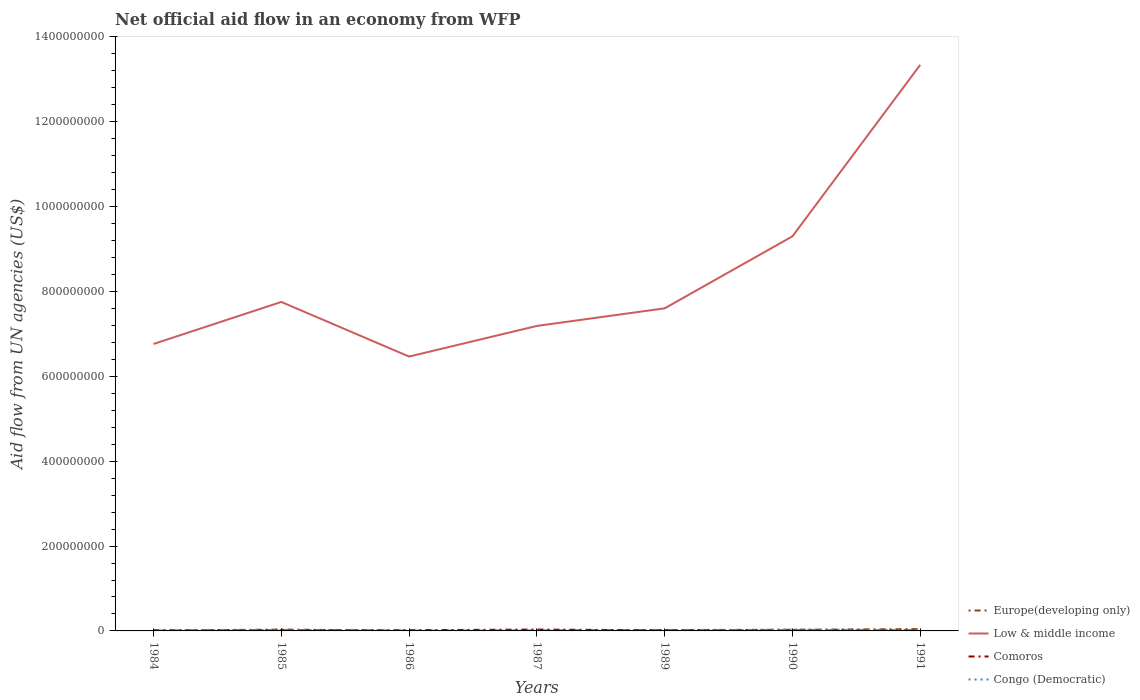Is the number of lines equal to the number of legend labels?
Your answer should be very brief. Yes. Across all years, what is the maximum net official aid flow in Europe(developing only)?
Ensure brevity in your answer.  4.70e+05. What is the total net official aid flow in Europe(developing only) in the graph?
Your answer should be compact. 2.37e+06. What is the difference between the highest and the second highest net official aid flow in Congo (Democratic)?
Keep it short and to the point. 3.17e+06. What is the difference between the highest and the lowest net official aid flow in Comoros?
Your response must be concise. 2. Does the graph contain grids?
Provide a short and direct response. No. How many legend labels are there?
Offer a very short reply. 4. How are the legend labels stacked?
Your answer should be compact. Vertical. What is the title of the graph?
Keep it short and to the point. Net official aid flow in an economy from WFP. What is the label or title of the Y-axis?
Your answer should be very brief. Aid flow from UN agencies (US$). What is the Aid flow from UN agencies (US$) of Europe(developing only) in 1984?
Provide a succinct answer. 5.50e+05. What is the Aid flow from UN agencies (US$) of Low & middle income in 1984?
Give a very brief answer. 6.76e+08. What is the Aid flow from UN agencies (US$) in Comoros in 1984?
Offer a terse response. 1.48e+06. What is the Aid flow from UN agencies (US$) in Europe(developing only) in 1985?
Your answer should be very brief. 3.30e+06. What is the Aid flow from UN agencies (US$) of Low & middle income in 1985?
Offer a very short reply. 7.75e+08. What is the Aid flow from UN agencies (US$) in Comoros in 1985?
Make the answer very short. 1.28e+06. What is the Aid flow from UN agencies (US$) of Congo (Democratic) in 1985?
Provide a short and direct response. 2.42e+06. What is the Aid flow from UN agencies (US$) of Europe(developing only) in 1986?
Give a very brief answer. 4.70e+05. What is the Aid flow from UN agencies (US$) in Low & middle income in 1986?
Your answer should be very brief. 6.47e+08. What is the Aid flow from UN agencies (US$) of Comoros in 1986?
Make the answer very short. 1.69e+06. What is the Aid flow from UN agencies (US$) in Congo (Democratic) in 1986?
Your answer should be compact. 1.80e+05. What is the Aid flow from UN agencies (US$) of Europe(developing only) in 1987?
Offer a terse response. 9.30e+05. What is the Aid flow from UN agencies (US$) of Low & middle income in 1987?
Your answer should be very brief. 7.19e+08. What is the Aid flow from UN agencies (US$) of Comoros in 1987?
Your answer should be compact. 3.21e+06. What is the Aid flow from UN agencies (US$) in Congo (Democratic) in 1987?
Provide a short and direct response. 7.20e+05. What is the Aid flow from UN agencies (US$) in Europe(developing only) in 1989?
Offer a very short reply. 2.12e+06. What is the Aid flow from UN agencies (US$) in Low & middle income in 1989?
Offer a terse response. 7.60e+08. What is the Aid flow from UN agencies (US$) of Comoros in 1989?
Make the answer very short. 1.46e+06. What is the Aid flow from UN agencies (US$) in Congo (Democratic) in 1989?
Ensure brevity in your answer.  4.40e+05. What is the Aid flow from UN agencies (US$) of Europe(developing only) in 1990?
Your response must be concise. 2.73e+06. What is the Aid flow from UN agencies (US$) of Low & middle income in 1990?
Offer a very short reply. 9.30e+08. What is the Aid flow from UN agencies (US$) of Comoros in 1990?
Your answer should be compact. 1.21e+06. What is the Aid flow from UN agencies (US$) in Congo (Democratic) in 1990?
Provide a short and direct response. 3.23e+06. What is the Aid flow from UN agencies (US$) of Europe(developing only) in 1991?
Your response must be concise. 4.31e+06. What is the Aid flow from UN agencies (US$) in Low & middle income in 1991?
Offer a terse response. 1.33e+09. What is the Aid flow from UN agencies (US$) of Comoros in 1991?
Your answer should be very brief. 9.40e+05. What is the Aid flow from UN agencies (US$) in Congo (Democratic) in 1991?
Your answer should be very brief. 2.19e+06. Across all years, what is the maximum Aid flow from UN agencies (US$) in Europe(developing only)?
Your response must be concise. 4.31e+06. Across all years, what is the maximum Aid flow from UN agencies (US$) in Low & middle income?
Make the answer very short. 1.33e+09. Across all years, what is the maximum Aid flow from UN agencies (US$) of Comoros?
Your answer should be compact. 3.21e+06. Across all years, what is the maximum Aid flow from UN agencies (US$) in Congo (Democratic)?
Offer a terse response. 3.23e+06. Across all years, what is the minimum Aid flow from UN agencies (US$) in Low & middle income?
Provide a short and direct response. 6.47e+08. Across all years, what is the minimum Aid flow from UN agencies (US$) in Comoros?
Give a very brief answer. 9.40e+05. Across all years, what is the minimum Aid flow from UN agencies (US$) of Congo (Democratic)?
Provide a short and direct response. 6.00e+04. What is the total Aid flow from UN agencies (US$) in Europe(developing only) in the graph?
Give a very brief answer. 1.44e+07. What is the total Aid flow from UN agencies (US$) in Low & middle income in the graph?
Give a very brief answer. 5.84e+09. What is the total Aid flow from UN agencies (US$) of Comoros in the graph?
Your answer should be compact. 1.13e+07. What is the total Aid flow from UN agencies (US$) in Congo (Democratic) in the graph?
Your response must be concise. 9.24e+06. What is the difference between the Aid flow from UN agencies (US$) in Europe(developing only) in 1984 and that in 1985?
Keep it short and to the point. -2.75e+06. What is the difference between the Aid flow from UN agencies (US$) of Low & middle income in 1984 and that in 1985?
Make the answer very short. -9.91e+07. What is the difference between the Aid flow from UN agencies (US$) of Congo (Democratic) in 1984 and that in 1985?
Your answer should be very brief. -2.36e+06. What is the difference between the Aid flow from UN agencies (US$) in Low & middle income in 1984 and that in 1986?
Provide a short and direct response. 2.97e+07. What is the difference between the Aid flow from UN agencies (US$) in Comoros in 1984 and that in 1986?
Provide a short and direct response. -2.10e+05. What is the difference between the Aid flow from UN agencies (US$) of Congo (Democratic) in 1984 and that in 1986?
Make the answer very short. -1.20e+05. What is the difference between the Aid flow from UN agencies (US$) in Europe(developing only) in 1984 and that in 1987?
Provide a succinct answer. -3.80e+05. What is the difference between the Aid flow from UN agencies (US$) in Low & middle income in 1984 and that in 1987?
Provide a short and direct response. -4.26e+07. What is the difference between the Aid flow from UN agencies (US$) of Comoros in 1984 and that in 1987?
Provide a short and direct response. -1.73e+06. What is the difference between the Aid flow from UN agencies (US$) in Congo (Democratic) in 1984 and that in 1987?
Provide a succinct answer. -6.60e+05. What is the difference between the Aid flow from UN agencies (US$) of Europe(developing only) in 1984 and that in 1989?
Ensure brevity in your answer.  -1.57e+06. What is the difference between the Aid flow from UN agencies (US$) of Low & middle income in 1984 and that in 1989?
Your answer should be compact. -8.40e+07. What is the difference between the Aid flow from UN agencies (US$) in Congo (Democratic) in 1984 and that in 1989?
Your answer should be compact. -3.80e+05. What is the difference between the Aid flow from UN agencies (US$) of Europe(developing only) in 1984 and that in 1990?
Your answer should be very brief. -2.18e+06. What is the difference between the Aid flow from UN agencies (US$) in Low & middle income in 1984 and that in 1990?
Your answer should be very brief. -2.54e+08. What is the difference between the Aid flow from UN agencies (US$) of Comoros in 1984 and that in 1990?
Provide a short and direct response. 2.70e+05. What is the difference between the Aid flow from UN agencies (US$) of Congo (Democratic) in 1984 and that in 1990?
Provide a succinct answer. -3.17e+06. What is the difference between the Aid flow from UN agencies (US$) of Europe(developing only) in 1984 and that in 1991?
Your answer should be compact. -3.76e+06. What is the difference between the Aid flow from UN agencies (US$) of Low & middle income in 1984 and that in 1991?
Offer a terse response. -6.58e+08. What is the difference between the Aid flow from UN agencies (US$) of Comoros in 1984 and that in 1991?
Provide a short and direct response. 5.40e+05. What is the difference between the Aid flow from UN agencies (US$) in Congo (Democratic) in 1984 and that in 1991?
Make the answer very short. -2.13e+06. What is the difference between the Aid flow from UN agencies (US$) in Europe(developing only) in 1985 and that in 1986?
Offer a terse response. 2.83e+06. What is the difference between the Aid flow from UN agencies (US$) in Low & middle income in 1985 and that in 1986?
Offer a very short reply. 1.29e+08. What is the difference between the Aid flow from UN agencies (US$) of Comoros in 1985 and that in 1986?
Provide a succinct answer. -4.10e+05. What is the difference between the Aid flow from UN agencies (US$) of Congo (Democratic) in 1985 and that in 1986?
Offer a very short reply. 2.24e+06. What is the difference between the Aid flow from UN agencies (US$) of Europe(developing only) in 1985 and that in 1987?
Your response must be concise. 2.37e+06. What is the difference between the Aid flow from UN agencies (US$) in Low & middle income in 1985 and that in 1987?
Provide a succinct answer. 5.65e+07. What is the difference between the Aid flow from UN agencies (US$) in Comoros in 1985 and that in 1987?
Provide a short and direct response. -1.93e+06. What is the difference between the Aid flow from UN agencies (US$) of Congo (Democratic) in 1985 and that in 1987?
Your response must be concise. 1.70e+06. What is the difference between the Aid flow from UN agencies (US$) of Europe(developing only) in 1985 and that in 1989?
Your answer should be compact. 1.18e+06. What is the difference between the Aid flow from UN agencies (US$) of Low & middle income in 1985 and that in 1989?
Provide a short and direct response. 1.51e+07. What is the difference between the Aid flow from UN agencies (US$) in Congo (Democratic) in 1985 and that in 1989?
Your response must be concise. 1.98e+06. What is the difference between the Aid flow from UN agencies (US$) in Europe(developing only) in 1985 and that in 1990?
Offer a terse response. 5.70e+05. What is the difference between the Aid flow from UN agencies (US$) of Low & middle income in 1985 and that in 1990?
Your answer should be very brief. -1.55e+08. What is the difference between the Aid flow from UN agencies (US$) in Congo (Democratic) in 1985 and that in 1990?
Make the answer very short. -8.10e+05. What is the difference between the Aid flow from UN agencies (US$) in Europe(developing only) in 1985 and that in 1991?
Keep it short and to the point. -1.01e+06. What is the difference between the Aid flow from UN agencies (US$) of Low & middle income in 1985 and that in 1991?
Offer a very short reply. -5.59e+08. What is the difference between the Aid flow from UN agencies (US$) in Congo (Democratic) in 1985 and that in 1991?
Provide a short and direct response. 2.30e+05. What is the difference between the Aid flow from UN agencies (US$) of Europe(developing only) in 1986 and that in 1987?
Provide a succinct answer. -4.60e+05. What is the difference between the Aid flow from UN agencies (US$) of Low & middle income in 1986 and that in 1987?
Give a very brief answer. -7.22e+07. What is the difference between the Aid flow from UN agencies (US$) of Comoros in 1986 and that in 1987?
Keep it short and to the point. -1.52e+06. What is the difference between the Aid flow from UN agencies (US$) in Congo (Democratic) in 1986 and that in 1987?
Keep it short and to the point. -5.40e+05. What is the difference between the Aid flow from UN agencies (US$) of Europe(developing only) in 1986 and that in 1989?
Your response must be concise. -1.65e+06. What is the difference between the Aid flow from UN agencies (US$) in Low & middle income in 1986 and that in 1989?
Provide a short and direct response. -1.14e+08. What is the difference between the Aid flow from UN agencies (US$) in Comoros in 1986 and that in 1989?
Your answer should be compact. 2.30e+05. What is the difference between the Aid flow from UN agencies (US$) in Europe(developing only) in 1986 and that in 1990?
Keep it short and to the point. -2.26e+06. What is the difference between the Aid flow from UN agencies (US$) in Low & middle income in 1986 and that in 1990?
Offer a very short reply. -2.83e+08. What is the difference between the Aid flow from UN agencies (US$) in Comoros in 1986 and that in 1990?
Make the answer very short. 4.80e+05. What is the difference between the Aid flow from UN agencies (US$) of Congo (Democratic) in 1986 and that in 1990?
Your answer should be compact. -3.05e+06. What is the difference between the Aid flow from UN agencies (US$) of Europe(developing only) in 1986 and that in 1991?
Your response must be concise. -3.84e+06. What is the difference between the Aid flow from UN agencies (US$) in Low & middle income in 1986 and that in 1991?
Offer a very short reply. -6.88e+08. What is the difference between the Aid flow from UN agencies (US$) of Comoros in 1986 and that in 1991?
Your response must be concise. 7.50e+05. What is the difference between the Aid flow from UN agencies (US$) of Congo (Democratic) in 1986 and that in 1991?
Ensure brevity in your answer.  -2.01e+06. What is the difference between the Aid flow from UN agencies (US$) of Europe(developing only) in 1987 and that in 1989?
Offer a very short reply. -1.19e+06. What is the difference between the Aid flow from UN agencies (US$) in Low & middle income in 1987 and that in 1989?
Your response must be concise. -4.15e+07. What is the difference between the Aid flow from UN agencies (US$) of Comoros in 1987 and that in 1989?
Keep it short and to the point. 1.75e+06. What is the difference between the Aid flow from UN agencies (US$) of Europe(developing only) in 1987 and that in 1990?
Ensure brevity in your answer.  -1.80e+06. What is the difference between the Aid flow from UN agencies (US$) of Low & middle income in 1987 and that in 1990?
Offer a terse response. -2.11e+08. What is the difference between the Aid flow from UN agencies (US$) of Congo (Democratic) in 1987 and that in 1990?
Make the answer very short. -2.51e+06. What is the difference between the Aid flow from UN agencies (US$) in Europe(developing only) in 1987 and that in 1991?
Your answer should be very brief. -3.38e+06. What is the difference between the Aid flow from UN agencies (US$) of Low & middle income in 1987 and that in 1991?
Offer a very short reply. -6.15e+08. What is the difference between the Aid flow from UN agencies (US$) of Comoros in 1987 and that in 1991?
Make the answer very short. 2.27e+06. What is the difference between the Aid flow from UN agencies (US$) in Congo (Democratic) in 1987 and that in 1991?
Your response must be concise. -1.47e+06. What is the difference between the Aid flow from UN agencies (US$) of Europe(developing only) in 1989 and that in 1990?
Offer a very short reply. -6.10e+05. What is the difference between the Aid flow from UN agencies (US$) of Low & middle income in 1989 and that in 1990?
Offer a very short reply. -1.70e+08. What is the difference between the Aid flow from UN agencies (US$) of Comoros in 1989 and that in 1990?
Keep it short and to the point. 2.50e+05. What is the difference between the Aid flow from UN agencies (US$) of Congo (Democratic) in 1989 and that in 1990?
Keep it short and to the point. -2.79e+06. What is the difference between the Aid flow from UN agencies (US$) in Europe(developing only) in 1989 and that in 1991?
Provide a succinct answer. -2.19e+06. What is the difference between the Aid flow from UN agencies (US$) in Low & middle income in 1989 and that in 1991?
Provide a short and direct response. -5.74e+08. What is the difference between the Aid flow from UN agencies (US$) in Comoros in 1989 and that in 1991?
Give a very brief answer. 5.20e+05. What is the difference between the Aid flow from UN agencies (US$) in Congo (Democratic) in 1989 and that in 1991?
Offer a very short reply. -1.75e+06. What is the difference between the Aid flow from UN agencies (US$) in Europe(developing only) in 1990 and that in 1991?
Provide a succinct answer. -1.58e+06. What is the difference between the Aid flow from UN agencies (US$) of Low & middle income in 1990 and that in 1991?
Keep it short and to the point. -4.04e+08. What is the difference between the Aid flow from UN agencies (US$) of Comoros in 1990 and that in 1991?
Ensure brevity in your answer.  2.70e+05. What is the difference between the Aid flow from UN agencies (US$) in Congo (Democratic) in 1990 and that in 1991?
Make the answer very short. 1.04e+06. What is the difference between the Aid flow from UN agencies (US$) in Europe(developing only) in 1984 and the Aid flow from UN agencies (US$) in Low & middle income in 1985?
Your answer should be very brief. -7.75e+08. What is the difference between the Aid flow from UN agencies (US$) of Europe(developing only) in 1984 and the Aid flow from UN agencies (US$) of Comoros in 1985?
Your answer should be very brief. -7.30e+05. What is the difference between the Aid flow from UN agencies (US$) in Europe(developing only) in 1984 and the Aid flow from UN agencies (US$) in Congo (Democratic) in 1985?
Give a very brief answer. -1.87e+06. What is the difference between the Aid flow from UN agencies (US$) of Low & middle income in 1984 and the Aid flow from UN agencies (US$) of Comoros in 1985?
Offer a very short reply. 6.75e+08. What is the difference between the Aid flow from UN agencies (US$) of Low & middle income in 1984 and the Aid flow from UN agencies (US$) of Congo (Democratic) in 1985?
Keep it short and to the point. 6.74e+08. What is the difference between the Aid flow from UN agencies (US$) in Comoros in 1984 and the Aid flow from UN agencies (US$) in Congo (Democratic) in 1985?
Give a very brief answer. -9.40e+05. What is the difference between the Aid flow from UN agencies (US$) in Europe(developing only) in 1984 and the Aid flow from UN agencies (US$) in Low & middle income in 1986?
Offer a very short reply. -6.46e+08. What is the difference between the Aid flow from UN agencies (US$) of Europe(developing only) in 1984 and the Aid flow from UN agencies (US$) of Comoros in 1986?
Give a very brief answer. -1.14e+06. What is the difference between the Aid flow from UN agencies (US$) in Europe(developing only) in 1984 and the Aid flow from UN agencies (US$) in Congo (Democratic) in 1986?
Offer a very short reply. 3.70e+05. What is the difference between the Aid flow from UN agencies (US$) of Low & middle income in 1984 and the Aid flow from UN agencies (US$) of Comoros in 1986?
Offer a terse response. 6.75e+08. What is the difference between the Aid flow from UN agencies (US$) in Low & middle income in 1984 and the Aid flow from UN agencies (US$) in Congo (Democratic) in 1986?
Offer a terse response. 6.76e+08. What is the difference between the Aid flow from UN agencies (US$) in Comoros in 1984 and the Aid flow from UN agencies (US$) in Congo (Democratic) in 1986?
Provide a succinct answer. 1.30e+06. What is the difference between the Aid flow from UN agencies (US$) in Europe(developing only) in 1984 and the Aid flow from UN agencies (US$) in Low & middle income in 1987?
Ensure brevity in your answer.  -7.18e+08. What is the difference between the Aid flow from UN agencies (US$) of Europe(developing only) in 1984 and the Aid flow from UN agencies (US$) of Comoros in 1987?
Provide a short and direct response. -2.66e+06. What is the difference between the Aid flow from UN agencies (US$) in Low & middle income in 1984 and the Aid flow from UN agencies (US$) in Comoros in 1987?
Offer a very short reply. 6.73e+08. What is the difference between the Aid flow from UN agencies (US$) in Low & middle income in 1984 and the Aid flow from UN agencies (US$) in Congo (Democratic) in 1987?
Your answer should be very brief. 6.76e+08. What is the difference between the Aid flow from UN agencies (US$) in Comoros in 1984 and the Aid flow from UN agencies (US$) in Congo (Democratic) in 1987?
Offer a terse response. 7.60e+05. What is the difference between the Aid flow from UN agencies (US$) of Europe(developing only) in 1984 and the Aid flow from UN agencies (US$) of Low & middle income in 1989?
Make the answer very short. -7.60e+08. What is the difference between the Aid flow from UN agencies (US$) in Europe(developing only) in 1984 and the Aid flow from UN agencies (US$) in Comoros in 1989?
Make the answer very short. -9.10e+05. What is the difference between the Aid flow from UN agencies (US$) in Low & middle income in 1984 and the Aid flow from UN agencies (US$) in Comoros in 1989?
Your answer should be compact. 6.75e+08. What is the difference between the Aid flow from UN agencies (US$) of Low & middle income in 1984 and the Aid flow from UN agencies (US$) of Congo (Democratic) in 1989?
Keep it short and to the point. 6.76e+08. What is the difference between the Aid flow from UN agencies (US$) in Comoros in 1984 and the Aid flow from UN agencies (US$) in Congo (Democratic) in 1989?
Your answer should be very brief. 1.04e+06. What is the difference between the Aid flow from UN agencies (US$) in Europe(developing only) in 1984 and the Aid flow from UN agencies (US$) in Low & middle income in 1990?
Ensure brevity in your answer.  -9.29e+08. What is the difference between the Aid flow from UN agencies (US$) of Europe(developing only) in 1984 and the Aid flow from UN agencies (US$) of Comoros in 1990?
Provide a short and direct response. -6.60e+05. What is the difference between the Aid flow from UN agencies (US$) in Europe(developing only) in 1984 and the Aid flow from UN agencies (US$) in Congo (Democratic) in 1990?
Ensure brevity in your answer.  -2.68e+06. What is the difference between the Aid flow from UN agencies (US$) of Low & middle income in 1984 and the Aid flow from UN agencies (US$) of Comoros in 1990?
Provide a succinct answer. 6.75e+08. What is the difference between the Aid flow from UN agencies (US$) of Low & middle income in 1984 and the Aid flow from UN agencies (US$) of Congo (Democratic) in 1990?
Your answer should be very brief. 6.73e+08. What is the difference between the Aid flow from UN agencies (US$) of Comoros in 1984 and the Aid flow from UN agencies (US$) of Congo (Democratic) in 1990?
Your answer should be very brief. -1.75e+06. What is the difference between the Aid flow from UN agencies (US$) of Europe(developing only) in 1984 and the Aid flow from UN agencies (US$) of Low & middle income in 1991?
Your answer should be very brief. -1.33e+09. What is the difference between the Aid flow from UN agencies (US$) of Europe(developing only) in 1984 and the Aid flow from UN agencies (US$) of Comoros in 1991?
Make the answer very short. -3.90e+05. What is the difference between the Aid flow from UN agencies (US$) of Europe(developing only) in 1984 and the Aid flow from UN agencies (US$) of Congo (Democratic) in 1991?
Your answer should be compact. -1.64e+06. What is the difference between the Aid flow from UN agencies (US$) in Low & middle income in 1984 and the Aid flow from UN agencies (US$) in Comoros in 1991?
Provide a short and direct response. 6.75e+08. What is the difference between the Aid flow from UN agencies (US$) of Low & middle income in 1984 and the Aid flow from UN agencies (US$) of Congo (Democratic) in 1991?
Make the answer very short. 6.74e+08. What is the difference between the Aid flow from UN agencies (US$) of Comoros in 1984 and the Aid flow from UN agencies (US$) of Congo (Democratic) in 1991?
Make the answer very short. -7.10e+05. What is the difference between the Aid flow from UN agencies (US$) of Europe(developing only) in 1985 and the Aid flow from UN agencies (US$) of Low & middle income in 1986?
Give a very brief answer. -6.43e+08. What is the difference between the Aid flow from UN agencies (US$) of Europe(developing only) in 1985 and the Aid flow from UN agencies (US$) of Comoros in 1986?
Offer a very short reply. 1.61e+06. What is the difference between the Aid flow from UN agencies (US$) of Europe(developing only) in 1985 and the Aid flow from UN agencies (US$) of Congo (Democratic) in 1986?
Your answer should be compact. 3.12e+06. What is the difference between the Aid flow from UN agencies (US$) of Low & middle income in 1985 and the Aid flow from UN agencies (US$) of Comoros in 1986?
Your answer should be compact. 7.74e+08. What is the difference between the Aid flow from UN agencies (US$) of Low & middle income in 1985 and the Aid flow from UN agencies (US$) of Congo (Democratic) in 1986?
Give a very brief answer. 7.75e+08. What is the difference between the Aid flow from UN agencies (US$) in Comoros in 1985 and the Aid flow from UN agencies (US$) in Congo (Democratic) in 1986?
Your answer should be very brief. 1.10e+06. What is the difference between the Aid flow from UN agencies (US$) of Europe(developing only) in 1985 and the Aid flow from UN agencies (US$) of Low & middle income in 1987?
Keep it short and to the point. -7.16e+08. What is the difference between the Aid flow from UN agencies (US$) in Europe(developing only) in 1985 and the Aid flow from UN agencies (US$) in Comoros in 1987?
Your answer should be very brief. 9.00e+04. What is the difference between the Aid flow from UN agencies (US$) of Europe(developing only) in 1985 and the Aid flow from UN agencies (US$) of Congo (Democratic) in 1987?
Offer a very short reply. 2.58e+06. What is the difference between the Aid flow from UN agencies (US$) of Low & middle income in 1985 and the Aid flow from UN agencies (US$) of Comoros in 1987?
Provide a short and direct response. 7.72e+08. What is the difference between the Aid flow from UN agencies (US$) of Low & middle income in 1985 and the Aid flow from UN agencies (US$) of Congo (Democratic) in 1987?
Provide a succinct answer. 7.75e+08. What is the difference between the Aid flow from UN agencies (US$) in Comoros in 1985 and the Aid flow from UN agencies (US$) in Congo (Democratic) in 1987?
Keep it short and to the point. 5.60e+05. What is the difference between the Aid flow from UN agencies (US$) in Europe(developing only) in 1985 and the Aid flow from UN agencies (US$) in Low & middle income in 1989?
Keep it short and to the point. -7.57e+08. What is the difference between the Aid flow from UN agencies (US$) of Europe(developing only) in 1985 and the Aid flow from UN agencies (US$) of Comoros in 1989?
Provide a succinct answer. 1.84e+06. What is the difference between the Aid flow from UN agencies (US$) in Europe(developing only) in 1985 and the Aid flow from UN agencies (US$) in Congo (Democratic) in 1989?
Offer a very short reply. 2.86e+06. What is the difference between the Aid flow from UN agencies (US$) of Low & middle income in 1985 and the Aid flow from UN agencies (US$) of Comoros in 1989?
Your answer should be compact. 7.74e+08. What is the difference between the Aid flow from UN agencies (US$) in Low & middle income in 1985 and the Aid flow from UN agencies (US$) in Congo (Democratic) in 1989?
Provide a short and direct response. 7.75e+08. What is the difference between the Aid flow from UN agencies (US$) in Comoros in 1985 and the Aid flow from UN agencies (US$) in Congo (Democratic) in 1989?
Keep it short and to the point. 8.40e+05. What is the difference between the Aid flow from UN agencies (US$) in Europe(developing only) in 1985 and the Aid flow from UN agencies (US$) in Low & middle income in 1990?
Offer a terse response. -9.27e+08. What is the difference between the Aid flow from UN agencies (US$) of Europe(developing only) in 1985 and the Aid flow from UN agencies (US$) of Comoros in 1990?
Your answer should be compact. 2.09e+06. What is the difference between the Aid flow from UN agencies (US$) in Europe(developing only) in 1985 and the Aid flow from UN agencies (US$) in Congo (Democratic) in 1990?
Your answer should be very brief. 7.00e+04. What is the difference between the Aid flow from UN agencies (US$) in Low & middle income in 1985 and the Aid flow from UN agencies (US$) in Comoros in 1990?
Give a very brief answer. 7.74e+08. What is the difference between the Aid flow from UN agencies (US$) in Low & middle income in 1985 and the Aid flow from UN agencies (US$) in Congo (Democratic) in 1990?
Ensure brevity in your answer.  7.72e+08. What is the difference between the Aid flow from UN agencies (US$) of Comoros in 1985 and the Aid flow from UN agencies (US$) of Congo (Democratic) in 1990?
Your answer should be very brief. -1.95e+06. What is the difference between the Aid flow from UN agencies (US$) of Europe(developing only) in 1985 and the Aid flow from UN agencies (US$) of Low & middle income in 1991?
Provide a succinct answer. -1.33e+09. What is the difference between the Aid flow from UN agencies (US$) in Europe(developing only) in 1985 and the Aid flow from UN agencies (US$) in Comoros in 1991?
Your answer should be very brief. 2.36e+06. What is the difference between the Aid flow from UN agencies (US$) in Europe(developing only) in 1985 and the Aid flow from UN agencies (US$) in Congo (Democratic) in 1991?
Offer a very short reply. 1.11e+06. What is the difference between the Aid flow from UN agencies (US$) of Low & middle income in 1985 and the Aid flow from UN agencies (US$) of Comoros in 1991?
Provide a succinct answer. 7.74e+08. What is the difference between the Aid flow from UN agencies (US$) of Low & middle income in 1985 and the Aid flow from UN agencies (US$) of Congo (Democratic) in 1991?
Ensure brevity in your answer.  7.73e+08. What is the difference between the Aid flow from UN agencies (US$) in Comoros in 1985 and the Aid flow from UN agencies (US$) in Congo (Democratic) in 1991?
Give a very brief answer. -9.10e+05. What is the difference between the Aid flow from UN agencies (US$) of Europe(developing only) in 1986 and the Aid flow from UN agencies (US$) of Low & middle income in 1987?
Provide a short and direct response. -7.18e+08. What is the difference between the Aid flow from UN agencies (US$) of Europe(developing only) in 1986 and the Aid flow from UN agencies (US$) of Comoros in 1987?
Your response must be concise. -2.74e+06. What is the difference between the Aid flow from UN agencies (US$) of Europe(developing only) in 1986 and the Aid flow from UN agencies (US$) of Congo (Democratic) in 1987?
Give a very brief answer. -2.50e+05. What is the difference between the Aid flow from UN agencies (US$) in Low & middle income in 1986 and the Aid flow from UN agencies (US$) in Comoros in 1987?
Your response must be concise. 6.43e+08. What is the difference between the Aid flow from UN agencies (US$) of Low & middle income in 1986 and the Aid flow from UN agencies (US$) of Congo (Democratic) in 1987?
Offer a terse response. 6.46e+08. What is the difference between the Aid flow from UN agencies (US$) of Comoros in 1986 and the Aid flow from UN agencies (US$) of Congo (Democratic) in 1987?
Provide a short and direct response. 9.70e+05. What is the difference between the Aid flow from UN agencies (US$) of Europe(developing only) in 1986 and the Aid flow from UN agencies (US$) of Low & middle income in 1989?
Keep it short and to the point. -7.60e+08. What is the difference between the Aid flow from UN agencies (US$) in Europe(developing only) in 1986 and the Aid flow from UN agencies (US$) in Comoros in 1989?
Keep it short and to the point. -9.90e+05. What is the difference between the Aid flow from UN agencies (US$) of Europe(developing only) in 1986 and the Aid flow from UN agencies (US$) of Congo (Democratic) in 1989?
Provide a succinct answer. 3.00e+04. What is the difference between the Aid flow from UN agencies (US$) of Low & middle income in 1986 and the Aid flow from UN agencies (US$) of Comoros in 1989?
Give a very brief answer. 6.45e+08. What is the difference between the Aid flow from UN agencies (US$) in Low & middle income in 1986 and the Aid flow from UN agencies (US$) in Congo (Democratic) in 1989?
Your response must be concise. 6.46e+08. What is the difference between the Aid flow from UN agencies (US$) of Comoros in 1986 and the Aid flow from UN agencies (US$) of Congo (Democratic) in 1989?
Keep it short and to the point. 1.25e+06. What is the difference between the Aid flow from UN agencies (US$) in Europe(developing only) in 1986 and the Aid flow from UN agencies (US$) in Low & middle income in 1990?
Your answer should be compact. -9.30e+08. What is the difference between the Aid flow from UN agencies (US$) of Europe(developing only) in 1986 and the Aid flow from UN agencies (US$) of Comoros in 1990?
Make the answer very short. -7.40e+05. What is the difference between the Aid flow from UN agencies (US$) in Europe(developing only) in 1986 and the Aid flow from UN agencies (US$) in Congo (Democratic) in 1990?
Ensure brevity in your answer.  -2.76e+06. What is the difference between the Aid flow from UN agencies (US$) of Low & middle income in 1986 and the Aid flow from UN agencies (US$) of Comoros in 1990?
Keep it short and to the point. 6.45e+08. What is the difference between the Aid flow from UN agencies (US$) of Low & middle income in 1986 and the Aid flow from UN agencies (US$) of Congo (Democratic) in 1990?
Keep it short and to the point. 6.43e+08. What is the difference between the Aid flow from UN agencies (US$) in Comoros in 1986 and the Aid flow from UN agencies (US$) in Congo (Democratic) in 1990?
Your answer should be very brief. -1.54e+06. What is the difference between the Aid flow from UN agencies (US$) in Europe(developing only) in 1986 and the Aid flow from UN agencies (US$) in Low & middle income in 1991?
Your answer should be compact. -1.33e+09. What is the difference between the Aid flow from UN agencies (US$) in Europe(developing only) in 1986 and the Aid flow from UN agencies (US$) in Comoros in 1991?
Make the answer very short. -4.70e+05. What is the difference between the Aid flow from UN agencies (US$) in Europe(developing only) in 1986 and the Aid flow from UN agencies (US$) in Congo (Democratic) in 1991?
Offer a terse response. -1.72e+06. What is the difference between the Aid flow from UN agencies (US$) of Low & middle income in 1986 and the Aid flow from UN agencies (US$) of Comoros in 1991?
Provide a short and direct response. 6.46e+08. What is the difference between the Aid flow from UN agencies (US$) in Low & middle income in 1986 and the Aid flow from UN agencies (US$) in Congo (Democratic) in 1991?
Provide a succinct answer. 6.44e+08. What is the difference between the Aid flow from UN agencies (US$) of Comoros in 1986 and the Aid flow from UN agencies (US$) of Congo (Democratic) in 1991?
Offer a terse response. -5.00e+05. What is the difference between the Aid flow from UN agencies (US$) of Europe(developing only) in 1987 and the Aid flow from UN agencies (US$) of Low & middle income in 1989?
Make the answer very short. -7.59e+08. What is the difference between the Aid flow from UN agencies (US$) of Europe(developing only) in 1987 and the Aid flow from UN agencies (US$) of Comoros in 1989?
Your response must be concise. -5.30e+05. What is the difference between the Aid flow from UN agencies (US$) in Low & middle income in 1987 and the Aid flow from UN agencies (US$) in Comoros in 1989?
Make the answer very short. 7.17e+08. What is the difference between the Aid flow from UN agencies (US$) in Low & middle income in 1987 and the Aid flow from UN agencies (US$) in Congo (Democratic) in 1989?
Make the answer very short. 7.18e+08. What is the difference between the Aid flow from UN agencies (US$) in Comoros in 1987 and the Aid flow from UN agencies (US$) in Congo (Democratic) in 1989?
Offer a terse response. 2.77e+06. What is the difference between the Aid flow from UN agencies (US$) of Europe(developing only) in 1987 and the Aid flow from UN agencies (US$) of Low & middle income in 1990?
Ensure brevity in your answer.  -9.29e+08. What is the difference between the Aid flow from UN agencies (US$) in Europe(developing only) in 1987 and the Aid flow from UN agencies (US$) in Comoros in 1990?
Provide a short and direct response. -2.80e+05. What is the difference between the Aid flow from UN agencies (US$) in Europe(developing only) in 1987 and the Aid flow from UN agencies (US$) in Congo (Democratic) in 1990?
Your answer should be very brief. -2.30e+06. What is the difference between the Aid flow from UN agencies (US$) of Low & middle income in 1987 and the Aid flow from UN agencies (US$) of Comoros in 1990?
Offer a very short reply. 7.18e+08. What is the difference between the Aid flow from UN agencies (US$) of Low & middle income in 1987 and the Aid flow from UN agencies (US$) of Congo (Democratic) in 1990?
Provide a succinct answer. 7.16e+08. What is the difference between the Aid flow from UN agencies (US$) in Comoros in 1987 and the Aid flow from UN agencies (US$) in Congo (Democratic) in 1990?
Provide a short and direct response. -2.00e+04. What is the difference between the Aid flow from UN agencies (US$) of Europe(developing only) in 1987 and the Aid flow from UN agencies (US$) of Low & middle income in 1991?
Your answer should be very brief. -1.33e+09. What is the difference between the Aid flow from UN agencies (US$) in Europe(developing only) in 1987 and the Aid flow from UN agencies (US$) in Comoros in 1991?
Your answer should be very brief. -10000. What is the difference between the Aid flow from UN agencies (US$) of Europe(developing only) in 1987 and the Aid flow from UN agencies (US$) of Congo (Democratic) in 1991?
Provide a succinct answer. -1.26e+06. What is the difference between the Aid flow from UN agencies (US$) in Low & middle income in 1987 and the Aid flow from UN agencies (US$) in Comoros in 1991?
Your response must be concise. 7.18e+08. What is the difference between the Aid flow from UN agencies (US$) of Low & middle income in 1987 and the Aid flow from UN agencies (US$) of Congo (Democratic) in 1991?
Keep it short and to the point. 7.17e+08. What is the difference between the Aid flow from UN agencies (US$) in Comoros in 1987 and the Aid flow from UN agencies (US$) in Congo (Democratic) in 1991?
Keep it short and to the point. 1.02e+06. What is the difference between the Aid flow from UN agencies (US$) in Europe(developing only) in 1989 and the Aid flow from UN agencies (US$) in Low & middle income in 1990?
Ensure brevity in your answer.  -9.28e+08. What is the difference between the Aid flow from UN agencies (US$) in Europe(developing only) in 1989 and the Aid flow from UN agencies (US$) in Comoros in 1990?
Make the answer very short. 9.10e+05. What is the difference between the Aid flow from UN agencies (US$) of Europe(developing only) in 1989 and the Aid flow from UN agencies (US$) of Congo (Democratic) in 1990?
Offer a very short reply. -1.11e+06. What is the difference between the Aid flow from UN agencies (US$) of Low & middle income in 1989 and the Aid flow from UN agencies (US$) of Comoros in 1990?
Your answer should be very brief. 7.59e+08. What is the difference between the Aid flow from UN agencies (US$) of Low & middle income in 1989 and the Aid flow from UN agencies (US$) of Congo (Democratic) in 1990?
Ensure brevity in your answer.  7.57e+08. What is the difference between the Aid flow from UN agencies (US$) of Comoros in 1989 and the Aid flow from UN agencies (US$) of Congo (Democratic) in 1990?
Keep it short and to the point. -1.77e+06. What is the difference between the Aid flow from UN agencies (US$) in Europe(developing only) in 1989 and the Aid flow from UN agencies (US$) in Low & middle income in 1991?
Your response must be concise. -1.33e+09. What is the difference between the Aid flow from UN agencies (US$) in Europe(developing only) in 1989 and the Aid flow from UN agencies (US$) in Comoros in 1991?
Offer a terse response. 1.18e+06. What is the difference between the Aid flow from UN agencies (US$) in Europe(developing only) in 1989 and the Aid flow from UN agencies (US$) in Congo (Democratic) in 1991?
Your answer should be very brief. -7.00e+04. What is the difference between the Aid flow from UN agencies (US$) in Low & middle income in 1989 and the Aid flow from UN agencies (US$) in Comoros in 1991?
Make the answer very short. 7.59e+08. What is the difference between the Aid flow from UN agencies (US$) of Low & middle income in 1989 and the Aid flow from UN agencies (US$) of Congo (Democratic) in 1991?
Make the answer very short. 7.58e+08. What is the difference between the Aid flow from UN agencies (US$) in Comoros in 1989 and the Aid flow from UN agencies (US$) in Congo (Democratic) in 1991?
Offer a terse response. -7.30e+05. What is the difference between the Aid flow from UN agencies (US$) in Europe(developing only) in 1990 and the Aid flow from UN agencies (US$) in Low & middle income in 1991?
Ensure brevity in your answer.  -1.33e+09. What is the difference between the Aid flow from UN agencies (US$) of Europe(developing only) in 1990 and the Aid flow from UN agencies (US$) of Comoros in 1991?
Make the answer very short. 1.79e+06. What is the difference between the Aid flow from UN agencies (US$) in Europe(developing only) in 1990 and the Aid flow from UN agencies (US$) in Congo (Democratic) in 1991?
Provide a succinct answer. 5.40e+05. What is the difference between the Aid flow from UN agencies (US$) of Low & middle income in 1990 and the Aid flow from UN agencies (US$) of Comoros in 1991?
Give a very brief answer. 9.29e+08. What is the difference between the Aid flow from UN agencies (US$) in Low & middle income in 1990 and the Aid flow from UN agencies (US$) in Congo (Democratic) in 1991?
Make the answer very short. 9.28e+08. What is the difference between the Aid flow from UN agencies (US$) of Comoros in 1990 and the Aid flow from UN agencies (US$) of Congo (Democratic) in 1991?
Provide a short and direct response. -9.80e+05. What is the average Aid flow from UN agencies (US$) of Europe(developing only) per year?
Offer a very short reply. 2.06e+06. What is the average Aid flow from UN agencies (US$) in Low & middle income per year?
Ensure brevity in your answer.  8.35e+08. What is the average Aid flow from UN agencies (US$) in Comoros per year?
Your response must be concise. 1.61e+06. What is the average Aid flow from UN agencies (US$) of Congo (Democratic) per year?
Provide a short and direct response. 1.32e+06. In the year 1984, what is the difference between the Aid flow from UN agencies (US$) in Europe(developing only) and Aid flow from UN agencies (US$) in Low & middle income?
Make the answer very short. -6.76e+08. In the year 1984, what is the difference between the Aid flow from UN agencies (US$) in Europe(developing only) and Aid flow from UN agencies (US$) in Comoros?
Provide a succinct answer. -9.30e+05. In the year 1984, what is the difference between the Aid flow from UN agencies (US$) in Low & middle income and Aid flow from UN agencies (US$) in Comoros?
Your answer should be very brief. 6.75e+08. In the year 1984, what is the difference between the Aid flow from UN agencies (US$) of Low & middle income and Aid flow from UN agencies (US$) of Congo (Democratic)?
Keep it short and to the point. 6.76e+08. In the year 1984, what is the difference between the Aid flow from UN agencies (US$) of Comoros and Aid flow from UN agencies (US$) of Congo (Democratic)?
Offer a very short reply. 1.42e+06. In the year 1985, what is the difference between the Aid flow from UN agencies (US$) of Europe(developing only) and Aid flow from UN agencies (US$) of Low & middle income?
Give a very brief answer. -7.72e+08. In the year 1985, what is the difference between the Aid flow from UN agencies (US$) in Europe(developing only) and Aid flow from UN agencies (US$) in Comoros?
Ensure brevity in your answer.  2.02e+06. In the year 1985, what is the difference between the Aid flow from UN agencies (US$) in Europe(developing only) and Aid flow from UN agencies (US$) in Congo (Democratic)?
Give a very brief answer. 8.80e+05. In the year 1985, what is the difference between the Aid flow from UN agencies (US$) in Low & middle income and Aid flow from UN agencies (US$) in Comoros?
Ensure brevity in your answer.  7.74e+08. In the year 1985, what is the difference between the Aid flow from UN agencies (US$) of Low & middle income and Aid flow from UN agencies (US$) of Congo (Democratic)?
Give a very brief answer. 7.73e+08. In the year 1985, what is the difference between the Aid flow from UN agencies (US$) in Comoros and Aid flow from UN agencies (US$) in Congo (Democratic)?
Provide a short and direct response. -1.14e+06. In the year 1986, what is the difference between the Aid flow from UN agencies (US$) of Europe(developing only) and Aid flow from UN agencies (US$) of Low & middle income?
Your answer should be compact. -6.46e+08. In the year 1986, what is the difference between the Aid flow from UN agencies (US$) in Europe(developing only) and Aid flow from UN agencies (US$) in Comoros?
Your answer should be very brief. -1.22e+06. In the year 1986, what is the difference between the Aid flow from UN agencies (US$) of Europe(developing only) and Aid flow from UN agencies (US$) of Congo (Democratic)?
Your answer should be compact. 2.90e+05. In the year 1986, what is the difference between the Aid flow from UN agencies (US$) in Low & middle income and Aid flow from UN agencies (US$) in Comoros?
Your answer should be compact. 6.45e+08. In the year 1986, what is the difference between the Aid flow from UN agencies (US$) of Low & middle income and Aid flow from UN agencies (US$) of Congo (Democratic)?
Offer a terse response. 6.46e+08. In the year 1986, what is the difference between the Aid flow from UN agencies (US$) of Comoros and Aid flow from UN agencies (US$) of Congo (Democratic)?
Give a very brief answer. 1.51e+06. In the year 1987, what is the difference between the Aid flow from UN agencies (US$) in Europe(developing only) and Aid flow from UN agencies (US$) in Low & middle income?
Keep it short and to the point. -7.18e+08. In the year 1987, what is the difference between the Aid flow from UN agencies (US$) of Europe(developing only) and Aid flow from UN agencies (US$) of Comoros?
Ensure brevity in your answer.  -2.28e+06. In the year 1987, what is the difference between the Aid flow from UN agencies (US$) of Low & middle income and Aid flow from UN agencies (US$) of Comoros?
Ensure brevity in your answer.  7.16e+08. In the year 1987, what is the difference between the Aid flow from UN agencies (US$) of Low & middle income and Aid flow from UN agencies (US$) of Congo (Democratic)?
Your response must be concise. 7.18e+08. In the year 1987, what is the difference between the Aid flow from UN agencies (US$) of Comoros and Aid flow from UN agencies (US$) of Congo (Democratic)?
Your answer should be very brief. 2.49e+06. In the year 1989, what is the difference between the Aid flow from UN agencies (US$) in Europe(developing only) and Aid flow from UN agencies (US$) in Low & middle income?
Give a very brief answer. -7.58e+08. In the year 1989, what is the difference between the Aid flow from UN agencies (US$) in Europe(developing only) and Aid flow from UN agencies (US$) in Comoros?
Your response must be concise. 6.60e+05. In the year 1989, what is the difference between the Aid flow from UN agencies (US$) of Europe(developing only) and Aid flow from UN agencies (US$) of Congo (Democratic)?
Keep it short and to the point. 1.68e+06. In the year 1989, what is the difference between the Aid flow from UN agencies (US$) of Low & middle income and Aid flow from UN agencies (US$) of Comoros?
Keep it short and to the point. 7.59e+08. In the year 1989, what is the difference between the Aid flow from UN agencies (US$) in Low & middle income and Aid flow from UN agencies (US$) in Congo (Democratic)?
Your response must be concise. 7.60e+08. In the year 1989, what is the difference between the Aid flow from UN agencies (US$) of Comoros and Aid flow from UN agencies (US$) of Congo (Democratic)?
Your answer should be very brief. 1.02e+06. In the year 1990, what is the difference between the Aid flow from UN agencies (US$) of Europe(developing only) and Aid flow from UN agencies (US$) of Low & middle income?
Give a very brief answer. -9.27e+08. In the year 1990, what is the difference between the Aid flow from UN agencies (US$) in Europe(developing only) and Aid flow from UN agencies (US$) in Comoros?
Give a very brief answer. 1.52e+06. In the year 1990, what is the difference between the Aid flow from UN agencies (US$) in Europe(developing only) and Aid flow from UN agencies (US$) in Congo (Democratic)?
Give a very brief answer. -5.00e+05. In the year 1990, what is the difference between the Aid flow from UN agencies (US$) in Low & middle income and Aid flow from UN agencies (US$) in Comoros?
Keep it short and to the point. 9.29e+08. In the year 1990, what is the difference between the Aid flow from UN agencies (US$) in Low & middle income and Aid flow from UN agencies (US$) in Congo (Democratic)?
Offer a very short reply. 9.27e+08. In the year 1990, what is the difference between the Aid flow from UN agencies (US$) of Comoros and Aid flow from UN agencies (US$) of Congo (Democratic)?
Provide a succinct answer. -2.02e+06. In the year 1991, what is the difference between the Aid flow from UN agencies (US$) in Europe(developing only) and Aid flow from UN agencies (US$) in Low & middle income?
Offer a terse response. -1.33e+09. In the year 1991, what is the difference between the Aid flow from UN agencies (US$) in Europe(developing only) and Aid flow from UN agencies (US$) in Comoros?
Keep it short and to the point. 3.37e+06. In the year 1991, what is the difference between the Aid flow from UN agencies (US$) of Europe(developing only) and Aid flow from UN agencies (US$) of Congo (Democratic)?
Make the answer very short. 2.12e+06. In the year 1991, what is the difference between the Aid flow from UN agencies (US$) in Low & middle income and Aid flow from UN agencies (US$) in Comoros?
Make the answer very short. 1.33e+09. In the year 1991, what is the difference between the Aid flow from UN agencies (US$) in Low & middle income and Aid flow from UN agencies (US$) in Congo (Democratic)?
Ensure brevity in your answer.  1.33e+09. In the year 1991, what is the difference between the Aid flow from UN agencies (US$) of Comoros and Aid flow from UN agencies (US$) of Congo (Democratic)?
Your response must be concise. -1.25e+06. What is the ratio of the Aid flow from UN agencies (US$) in Low & middle income in 1984 to that in 1985?
Your response must be concise. 0.87. What is the ratio of the Aid flow from UN agencies (US$) in Comoros in 1984 to that in 1985?
Your response must be concise. 1.16. What is the ratio of the Aid flow from UN agencies (US$) in Congo (Democratic) in 1984 to that in 1985?
Keep it short and to the point. 0.02. What is the ratio of the Aid flow from UN agencies (US$) of Europe(developing only) in 1984 to that in 1986?
Make the answer very short. 1.17. What is the ratio of the Aid flow from UN agencies (US$) in Low & middle income in 1984 to that in 1986?
Your answer should be very brief. 1.05. What is the ratio of the Aid flow from UN agencies (US$) in Comoros in 1984 to that in 1986?
Your answer should be very brief. 0.88. What is the ratio of the Aid flow from UN agencies (US$) in Europe(developing only) in 1984 to that in 1987?
Offer a very short reply. 0.59. What is the ratio of the Aid flow from UN agencies (US$) in Low & middle income in 1984 to that in 1987?
Ensure brevity in your answer.  0.94. What is the ratio of the Aid flow from UN agencies (US$) of Comoros in 1984 to that in 1987?
Your response must be concise. 0.46. What is the ratio of the Aid flow from UN agencies (US$) of Congo (Democratic) in 1984 to that in 1987?
Your answer should be very brief. 0.08. What is the ratio of the Aid flow from UN agencies (US$) in Europe(developing only) in 1984 to that in 1989?
Give a very brief answer. 0.26. What is the ratio of the Aid flow from UN agencies (US$) in Low & middle income in 1984 to that in 1989?
Provide a short and direct response. 0.89. What is the ratio of the Aid flow from UN agencies (US$) of Comoros in 1984 to that in 1989?
Your answer should be very brief. 1.01. What is the ratio of the Aid flow from UN agencies (US$) in Congo (Democratic) in 1984 to that in 1989?
Ensure brevity in your answer.  0.14. What is the ratio of the Aid flow from UN agencies (US$) of Europe(developing only) in 1984 to that in 1990?
Offer a very short reply. 0.2. What is the ratio of the Aid flow from UN agencies (US$) of Low & middle income in 1984 to that in 1990?
Provide a short and direct response. 0.73. What is the ratio of the Aid flow from UN agencies (US$) in Comoros in 1984 to that in 1990?
Provide a succinct answer. 1.22. What is the ratio of the Aid flow from UN agencies (US$) in Congo (Democratic) in 1984 to that in 1990?
Keep it short and to the point. 0.02. What is the ratio of the Aid flow from UN agencies (US$) in Europe(developing only) in 1984 to that in 1991?
Ensure brevity in your answer.  0.13. What is the ratio of the Aid flow from UN agencies (US$) of Low & middle income in 1984 to that in 1991?
Your answer should be compact. 0.51. What is the ratio of the Aid flow from UN agencies (US$) of Comoros in 1984 to that in 1991?
Give a very brief answer. 1.57. What is the ratio of the Aid flow from UN agencies (US$) of Congo (Democratic) in 1984 to that in 1991?
Ensure brevity in your answer.  0.03. What is the ratio of the Aid flow from UN agencies (US$) of Europe(developing only) in 1985 to that in 1986?
Your response must be concise. 7.02. What is the ratio of the Aid flow from UN agencies (US$) of Low & middle income in 1985 to that in 1986?
Ensure brevity in your answer.  1.2. What is the ratio of the Aid flow from UN agencies (US$) of Comoros in 1985 to that in 1986?
Your response must be concise. 0.76. What is the ratio of the Aid flow from UN agencies (US$) of Congo (Democratic) in 1985 to that in 1986?
Keep it short and to the point. 13.44. What is the ratio of the Aid flow from UN agencies (US$) in Europe(developing only) in 1985 to that in 1987?
Your answer should be very brief. 3.55. What is the ratio of the Aid flow from UN agencies (US$) of Low & middle income in 1985 to that in 1987?
Offer a terse response. 1.08. What is the ratio of the Aid flow from UN agencies (US$) of Comoros in 1985 to that in 1987?
Keep it short and to the point. 0.4. What is the ratio of the Aid flow from UN agencies (US$) of Congo (Democratic) in 1985 to that in 1987?
Give a very brief answer. 3.36. What is the ratio of the Aid flow from UN agencies (US$) in Europe(developing only) in 1985 to that in 1989?
Give a very brief answer. 1.56. What is the ratio of the Aid flow from UN agencies (US$) of Low & middle income in 1985 to that in 1989?
Your answer should be very brief. 1.02. What is the ratio of the Aid flow from UN agencies (US$) in Comoros in 1985 to that in 1989?
Your response must be concise. 0.88. What is the ratio of the Aid flow from UN agencies (US$) in Congo (Democratic) in 1985 to that in 1989?
Your answer should be compact. 5.5. What is the ratio of the Aid flow from UN agencies (US$) in Europe(developing only) in 1985 to that in 1990?
Your answer should be very brief. 1.21. What is the ratio of the Aid flow from UN agencies (US$) of Low & middle income in 1985 to that in 1990?
Keep it short and to the point. 0.83. What is the ratio of the Aid flow from UN agencies (US$) in Comoros in 1985 to that in 1990?
Your answer should be very brief. 1.06. What is the ratio of the Aid flow from UN agencies (US$) of Congo (Democratic) in 1985 to that in 1990?
Your answer should be compact. 0.75. What is the ratio of the Aid flow from UN agencies (US$) of Europe(developing only) in 1985 to that in 1991?
Your answer should be compact. 0.77. What is the ratio of the Aid flow from UN agencies (US$) of Low & middle income in 1985 to that in 1991?
Offer a very short reply. 0.58. What is the ratio of the Aid flow from UN agencies (US$) in Comoros in 1985 to that in 1991?
Keep it short and to the point. 1.36. What is the ratio of the Aid flow from UN agencies (US$) in Congo (Democratic) in 1985 to that in 1991?
Your answer should be very brief. 1.1. What is the ratio of the Aid flow from UN agencies (US$) in Europe(developing only) in 1986 to that in 1987?
Provide a succinct answer. 0.51. What is the ratio of the Aid flow from UN agencies (US$) of Low & middle income in 1986 to that in 1987?
Give a very brief answer. 0.9. What is the ratio of the Aid flow from UN agencies (US$) of Comoros in 1986 to that in 1987?
Offer a very short reply. 0.53. What is the ratio of the Aid flow from UN agencies (US$) of Europe(developing only) in 1986 to that in 1989?
Your answer should be compact. 0.22. What is the ratio of the Aid flow from UN agencies (US$) of Low & middle income in 1986 to that in 1989?
Your answer should be compact. 0.85. What is the ratio of the Aid flow from UN agencies (US$) of Comoros in 1986 to that in 1989?
Your response must be concise. 1.16. What is the ratio of the Aid flow from UN agencies (US$) in Congo (Democratic) in 1986 to that in 1989?
Provide a succinct answer. 0.41. What is the ratio of the Aid flow from UN agencies (US$) of Europe(developing only) in 1986 to that in 1990?
Keep it short and to the point. 0.17. What is the ratio of the Aid flow from UN agencies (US$) in Low & middle income in 1986 to that in 1990?
Your answer should be very brief. 0.7. What is the ratio of the Aid flow from UN agencies (US$) in Comoros in 1986 to that in 1990?
Provide a short and direct response. 1.4. What is the ratio of the Aid flow from UN agencies (US$) in Congo (Democratic) in 1986 to that in 1990?
Offer a terse response. 0.06. What is the ratio of the Aid flow from UN agencies (US$) in Europe(developing only) in 1986 to that in 1991?
Provide a succinct answer. 0.11. What is the ratio of the Aid flow from UN agencies (US$) in Low & middle income in 1986 to that in 1991?
Ensure brevity in your answer.  0.48. What is the ratio of the Aid flow from UN agencies (US$) of Comoros in 1986 to that in 1991?
Ensure brevity in your answer.  1.8. What is the ratio of the Aid flow from UN agencies (US$) of Congo (Democratic) in 1986 to that in 1991?
Your answer should be very brief. 0.08. What is the ratio of the Aid flow from UN agencies (US$) in Europe(developing only) in 1987 to that in 1989?
Keep it short and to the point. 0.44. What is the ratio of the Aid flow from UN agencies (US$) in Low & middle income in 1987 to that in 1989?
Your answer should be compact. 0.95. What is the ratio of the Aid flow from UN agencies (US$) of Comoros in 1987 to that in 1989?
Your answer should be very brief. 2.2. What is the ratio of the Aid flow from UN agencies (US$) of Congo (Democratic) in 1987 to that in 1989?
Your answer should be very brief. 1.64. What is the ratio of the Aid flow from UN agencies (US$) in Europe(developing only) in 1987 to that in 1990?
Make the answer very short. 0.34. What is the ratio of the Aid flow from UN agencies (US$) in Low & middle income in 1987 to that in 1990?
Provide a short and direct response. 0.77. What is the ratio of the Aid flow from UN agencies (US$) of Comoros in 1987 to that in 1990?
Provide a succinct answer. 2.65. What is the ratio of the Aid flow from UN agencies (US$) in Congo (Democratic) in 1987 to that in 1990?
Your answer should be compact. 0.22. What is the ratio of the Aid flow from UN agencies (US$) of Europe(developing only) in 1987 to that in 1991?
Your answer should be compact. 0.22. What is the ratio of the Aid flow from UN agencies (US$) in Low & middle income in 1987 to that in 1991?
Keep it short and to the point. 0.54. What is the ratio of the Aid flow from UN agencies (US$) of Comoros in 1987 to that in 1991?
Your answer should be compact. 3.41. What is the ratio of the Aid flow from UN agencies (US$) of Congo (Democratic) in 1987 to that in 1991?
Keep it short and to the point. 0.33. What is the ratio of the Aid flow from UN agencies (US$) in Europe(developing only) in 1989 to that in 1990?
Give a very brief answer. 0.78. What is the ratio of the Aid flow from UN agencies (US$) of Low & middle income in 1989 to that in 1990?
Give a very brief answer. 0.82. What is the ratio of the Aid flow from UN agencies (US$) in Comoros in 1989 to that in 1990?
Provide a short and direct response. 1.21. What is the ratio of the Aid flow from UN agencies (US$) of Congo (Democratic) in 1989 to that in 1990?
Offer a very short reply. 0.14. What is the ratio of the Aid flow from UN agencies (US$) in Europe(developing only) in 1989 to that in 1991?
Make the answer very short. 0.49. What is the ratio of the Aid flow from UN agencies (US$) of Low & middle income in 1989 to that in 1991?
Give a very brief answer. 0.57. What is the ratio of the Aid flow from UN agencies (US$) in Comoros in 1989 to that in 1991?
Provide a short and direct response. 1.55. What is the ratio of the Aid flow from UN agencies (US$) of Congo (Democratic) in 1989 to that in 1991?
Your answer should be very brief. 0.2. What is the ratio of the Aid flow from UN agencies (US$) of Europe(developing only) in 1990 to that in 1991?
Your response must be concise. 0.63. What is the ratio of the Aid flow from UN agencies (US$) in Low & middle income in 1990 to that in 1991?
Your answer should be very brief. 0.7. What is the ratio of the Aid flow from UN agencies (US$) in Comoros in 1990 to that in 1991?
Offer a terse response. 1.29. What is the ratio of the Aid flow from UN agencies (US$) of Congo (Democratic) in 1990 to that in 1991?
Ensure brevity in your answer.  1.47. What is the difference between the highest and the second highest Aid flow from UN agencies (US$) of Europe(developing only)?
Your answer should be compact. 1.01e+06. What is the difference between the highest and the second highest Aid flow from UN agencies (US$) of Low & middle income?
Ensure brevity in your answer.  4.04e+08. What is the difference between the highest and the second highest Aid flow from UN agencies (US$) in Comoros?
Your response must be concise. 1.52e+06. What is the difference between the highest and the second highest Aid flow from UN agencies (US$) in Congo (Democratic)?
Ensure brevity in your answer.  8.10e+05. What is the difference between the highest and the lowest Aid flow from UN agencies (US$) of Europe(developing only)?
Keep it short and to the point. 3.84e+06. What is the difference between the highest and the lowest Aid flow from UN agencies (US$) of Low & middle income?
Ensure brevity in your answer.  6.88e+08. What is the difference between the highest and the lowest Aid flow from UN agencies (US$) in Comoros?
Provide a succinct answer. 2.27e+06. What is the difference between the highest and the lowest Aid flow from UN agencies (US$) in Congo (Democratic)?
Give a very brief answer. 3.17e+06. 